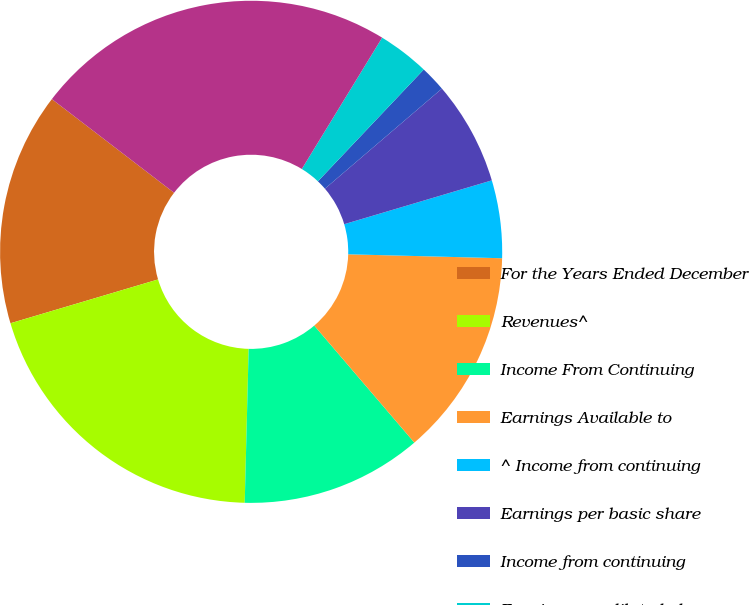Convert chart to OTSL. <chart><loc_0><loc_0><loc_500><loc_500><pie_chart><fcel>For the Years Ended December<fcel>Revenues^<fcel>Income From Continuing<fcel>Earnings Available to<fcel>^ Income from continuing<fcel>Earnings per basic share<fcel>Income from continuing<fcel>Earnings per diluted share<fcel>Dividends Declared per Share<fcel>Total Assets<nl><fcel>15.0%<fcel>20.0%<fcel>11.67%<fcel>13.33%<fcel>5.0%<fcel>6.67%<fcel>1.67%<fcel>3.33%<fcel>0.0%<fcel>23.33%<nl></chart> 